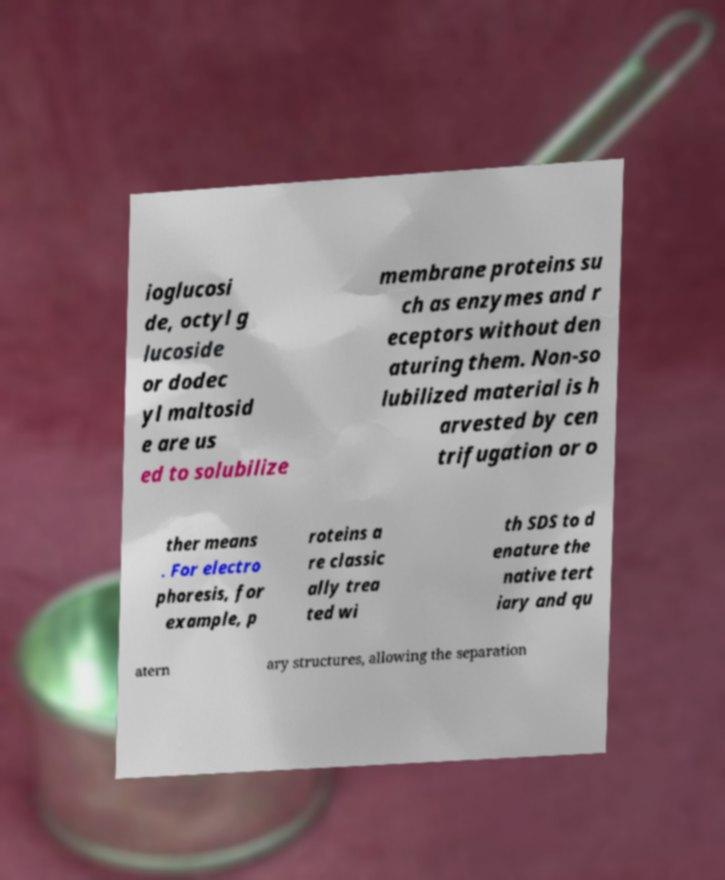Please read and relay the text visible in this image. What does it say? ioglucosi de, octyl g lucoside or dodec yl maltosid e are us ed to solubilize membrane proteins su ch as enzymes and r eceptors without den aturing them. Non-so lubilized material is h arvested by cen trifugation or o ther means . For electro phoresis, for example, p roteins a re classic ally trea ted wi th SDS to d enature the native tert iary and qu atern ary structures, allowing the separation 